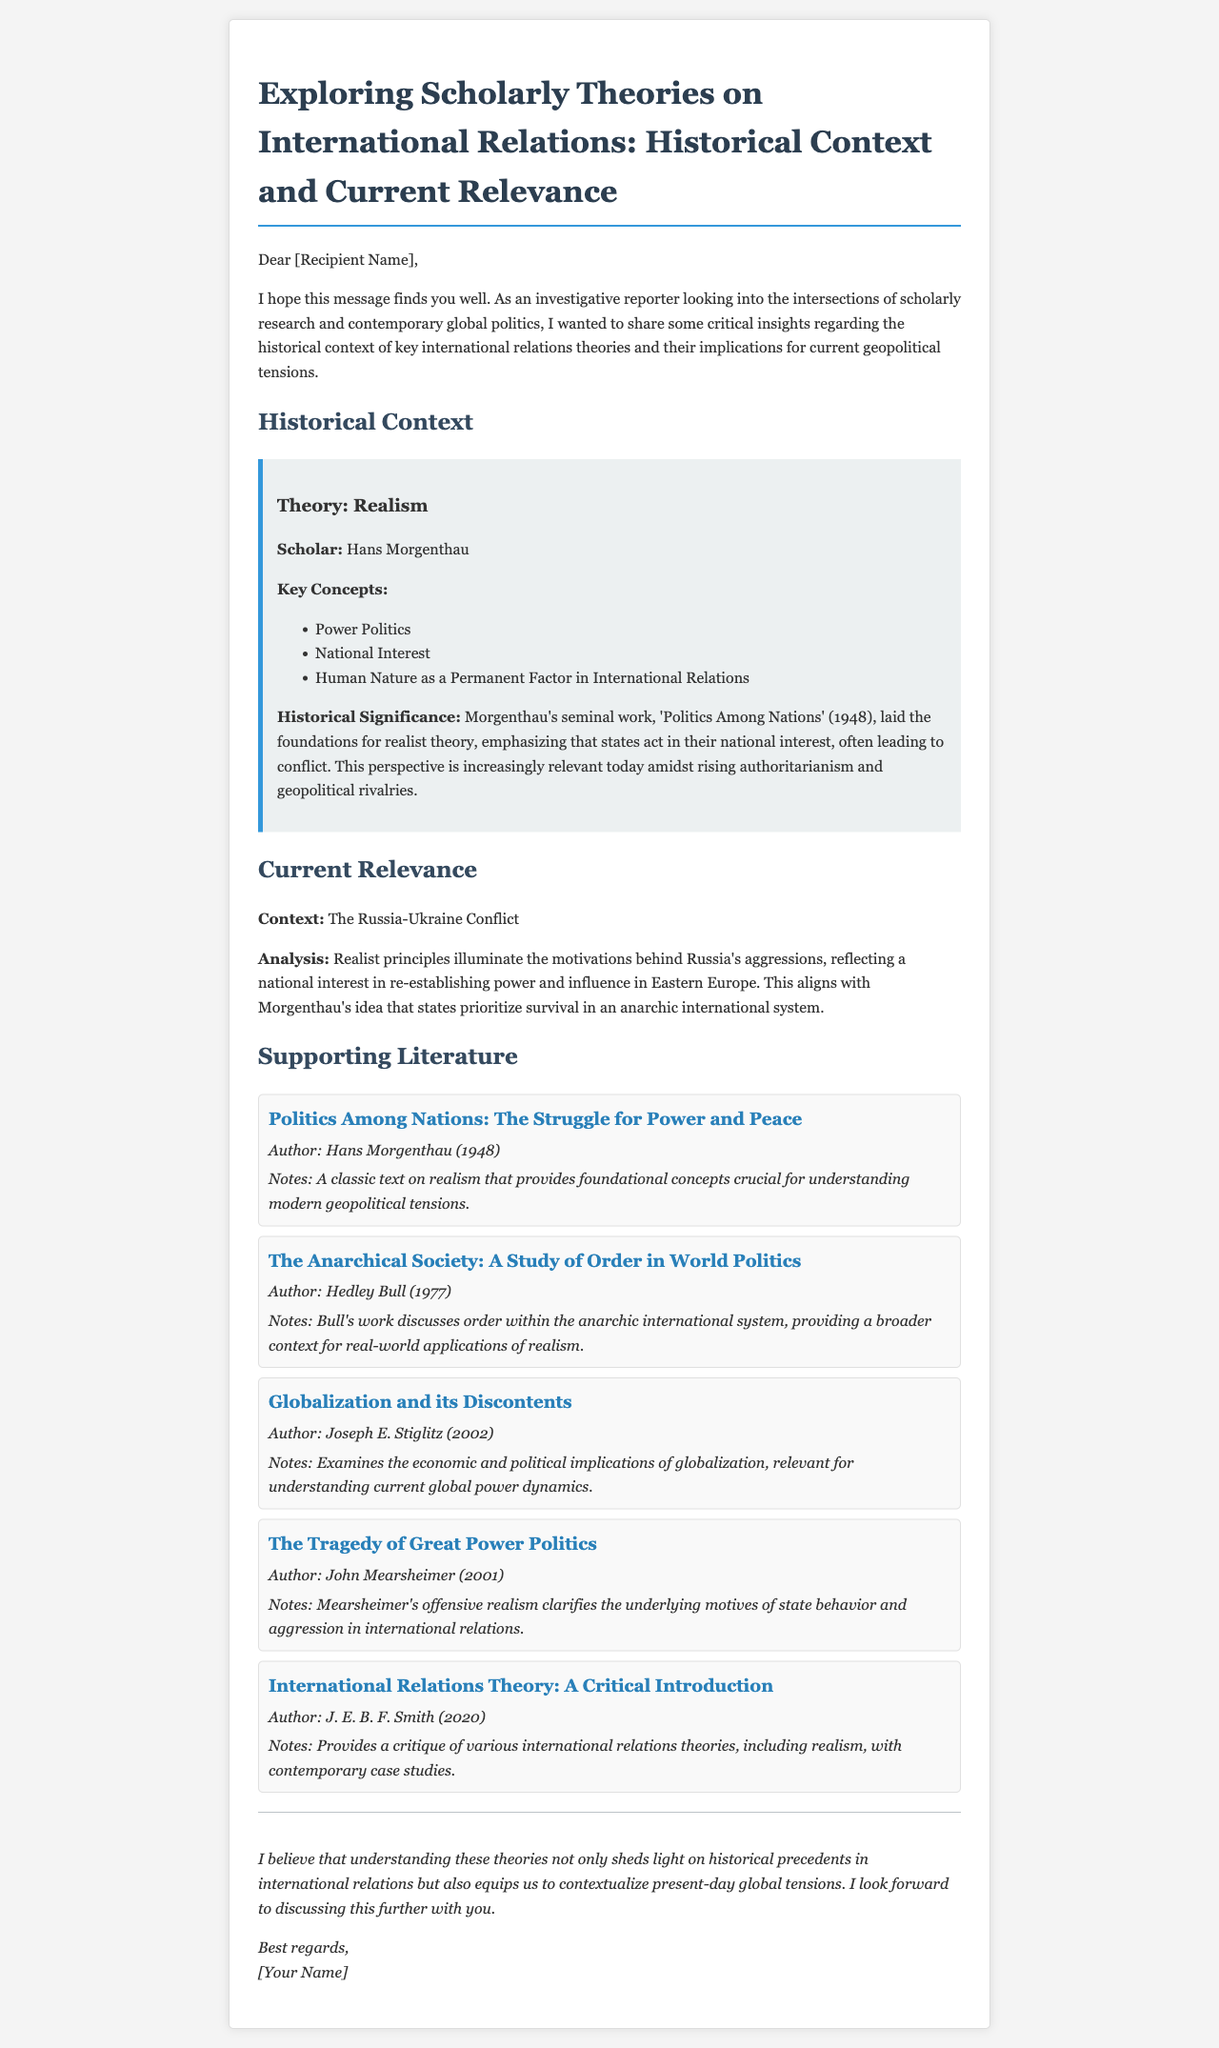What is the title of the email? The title of the email can be found in the header section, indicating the main topic discussed.
Answer: Exploring Scholarly Theories on International Relations: Historical Context and Current Relevance Who is the scholar associated with the theory of Realism? The document explicitly mentions the name of the scholar who developed the Realism theory.
Answer: Hans Morgenthau What year was "Politics Among Nations" published? The publication date of the key text by Hans Morgenthau is stated in the document.
Answer: 1948 Which geopolitical conflict is discussed as a context for Realism? The document refers to a specific ongoing conflict in relation to Realism and its principles.
Answer: The Russia-Ukraine Conflict What are the key concepts of Morgenthau's Realism? The email lists the main concepts that define Morgenthau's theory under Realism.
Answer: Power Politics, National Interest, Human Nature as a Permanent Factor in International Relations What does Morgenthau's theory emphasize regarding state actions? The email describes the fundamental principle of Morgenthau's theory concerning state motivations.
Answer: National interest Which author wrote "The Tragedy of Great Power Politics"? The document provides the name of the author of a significant work within the realism discourse.
Answer: John Mearsheimer What is the primary focus of Hedley Bull's work mentioned in the literature? The document highlights the main theme of Bull's book relevant to the discussion of international relations.
Answer: Order within the anarchic international system What does the email suggest about the relevance of historical theories? The conclusion of the email outlines the importance of historical theories in understanding contemporary issues.
Answer: Contextualize present-day global tensions 